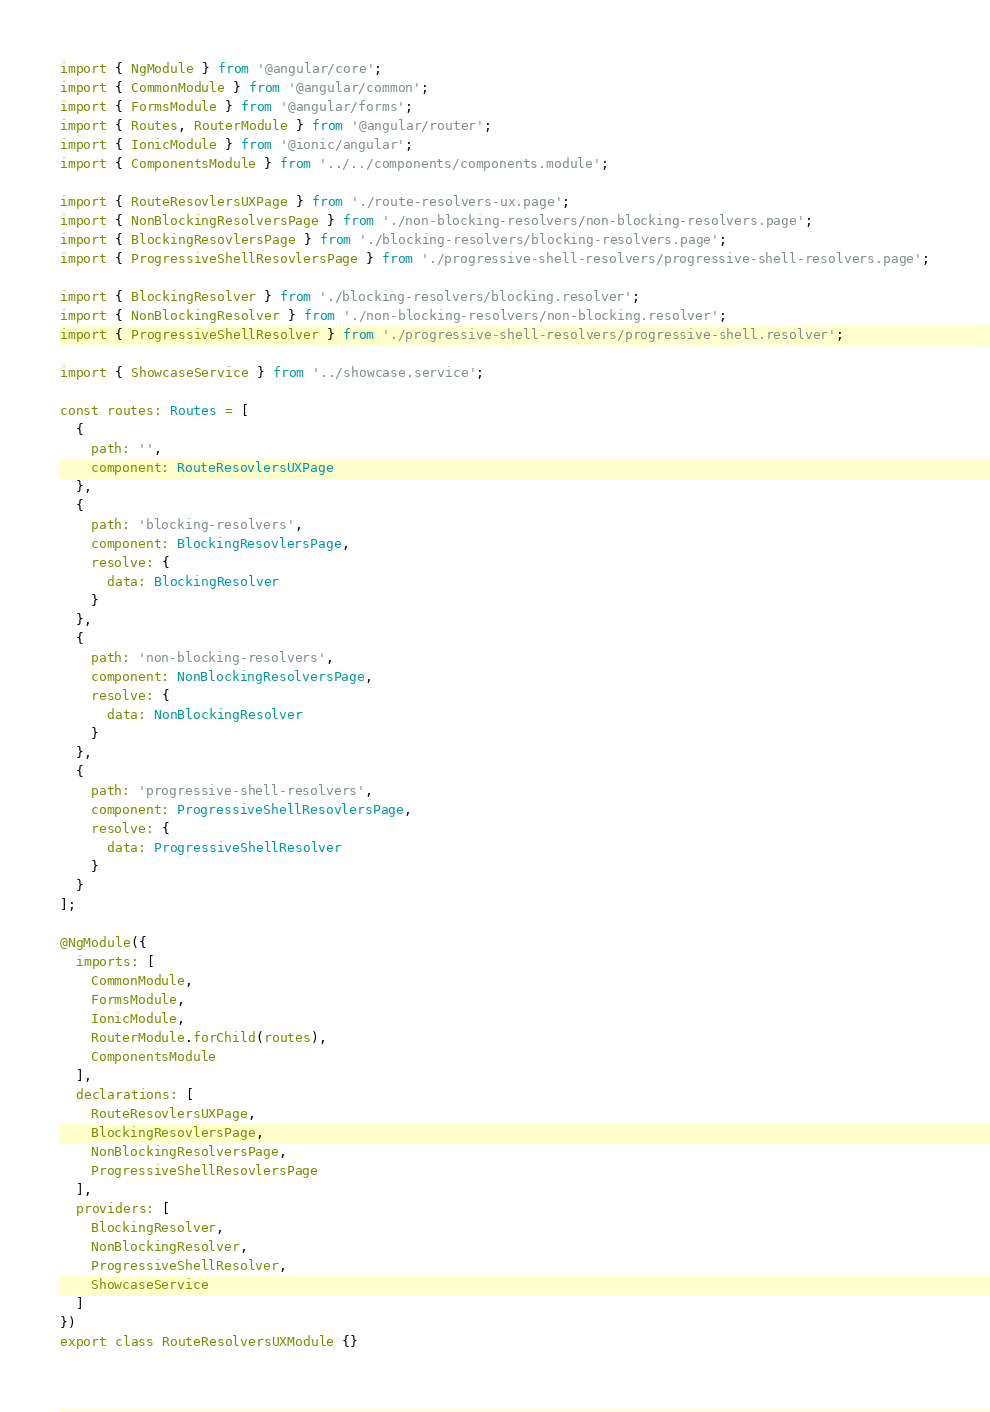<code> <loc_0><loc_0><loc_500><loc_500><_TypeScript_>import { NgModule } from '@angular/core';
import { CommonModule } from '@angular/common';
import { FormsModule } from '@angular/forms';
import { Routes, RouterModule } from '@angular/router';
import { IonicModule } from '@ionic/angular';
import { ComponentsModule } from '../../components/components.module';

import { RouteResovlersUXPage } from './route-resolvers-ux.page';
import { NonBlockingResolversPage } from './non-blocking-resolvers/non-blocking-resolvers.page';
import { BlockingResovlersPage } from './blocking-resolvers/blocking-resolvers.page';
import { ProgressiveShellResovlersPage } from './progressive-shell-resolvers/progressive-shell-resolvers.page';

import { BlockingResolver } from './blocking-resolvers/blocking.resolver';
import { NonBlockingResolver } from './non-blocking-resolvers/non-blocking.resolver';
import { ProgressiveShellResolver } from './progressive-shell-resolvers/progressive-shell.resolver';

import { ShowcaseService } from '../showcase.service';

const routes: Routes = [
  {
    path: '',
    component: RouteResovlersUXPage
  },
  {
    path: 'blocking-resolvers',
    component: BlockingResovlersPage,
    resolve: {
      data: BlockingResolver
    }
  },
  {
    path: 'non-blocking-resolvers',
    component: NonBlockingResolversPage,
    resolve: {
      data: NonBlockingResolver
    }
  },
  {
    path: 'progressive-shell-resolvers',
    component: ProgressiveShellResovlersPage,
    resolve: {
      data: ProgressiveShellResolver
    }
  }
];

@NgModule({
  imports: [
    CommonModule,
    FormsModule,
    IonicModule,
    RouterModule.forChild(routes),
    ComponentsModule
  ],
  declarations: [
    RouteResovlersUXPage,
    BlockingResovlersPage,
    NonBlockingResolversPage,
    ProgressiveShellResovlersPage
  ],
  providers: [
    BlockingResolver,
    NonBlockingResolver,
    ProgressiveShellResolver,
    ShowcaseService
  ]
})
export class RouteResolversUXModule {}
</code> 